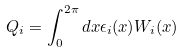Convert formula to latex. <formula><loc_0><loc_0><loc_500><loc_500>Q _ { i } = \int _ { 0 } ^ { 2 \pi } d x \epsilon _ { i } ( x ) W _ { i } ( x )</formula> 